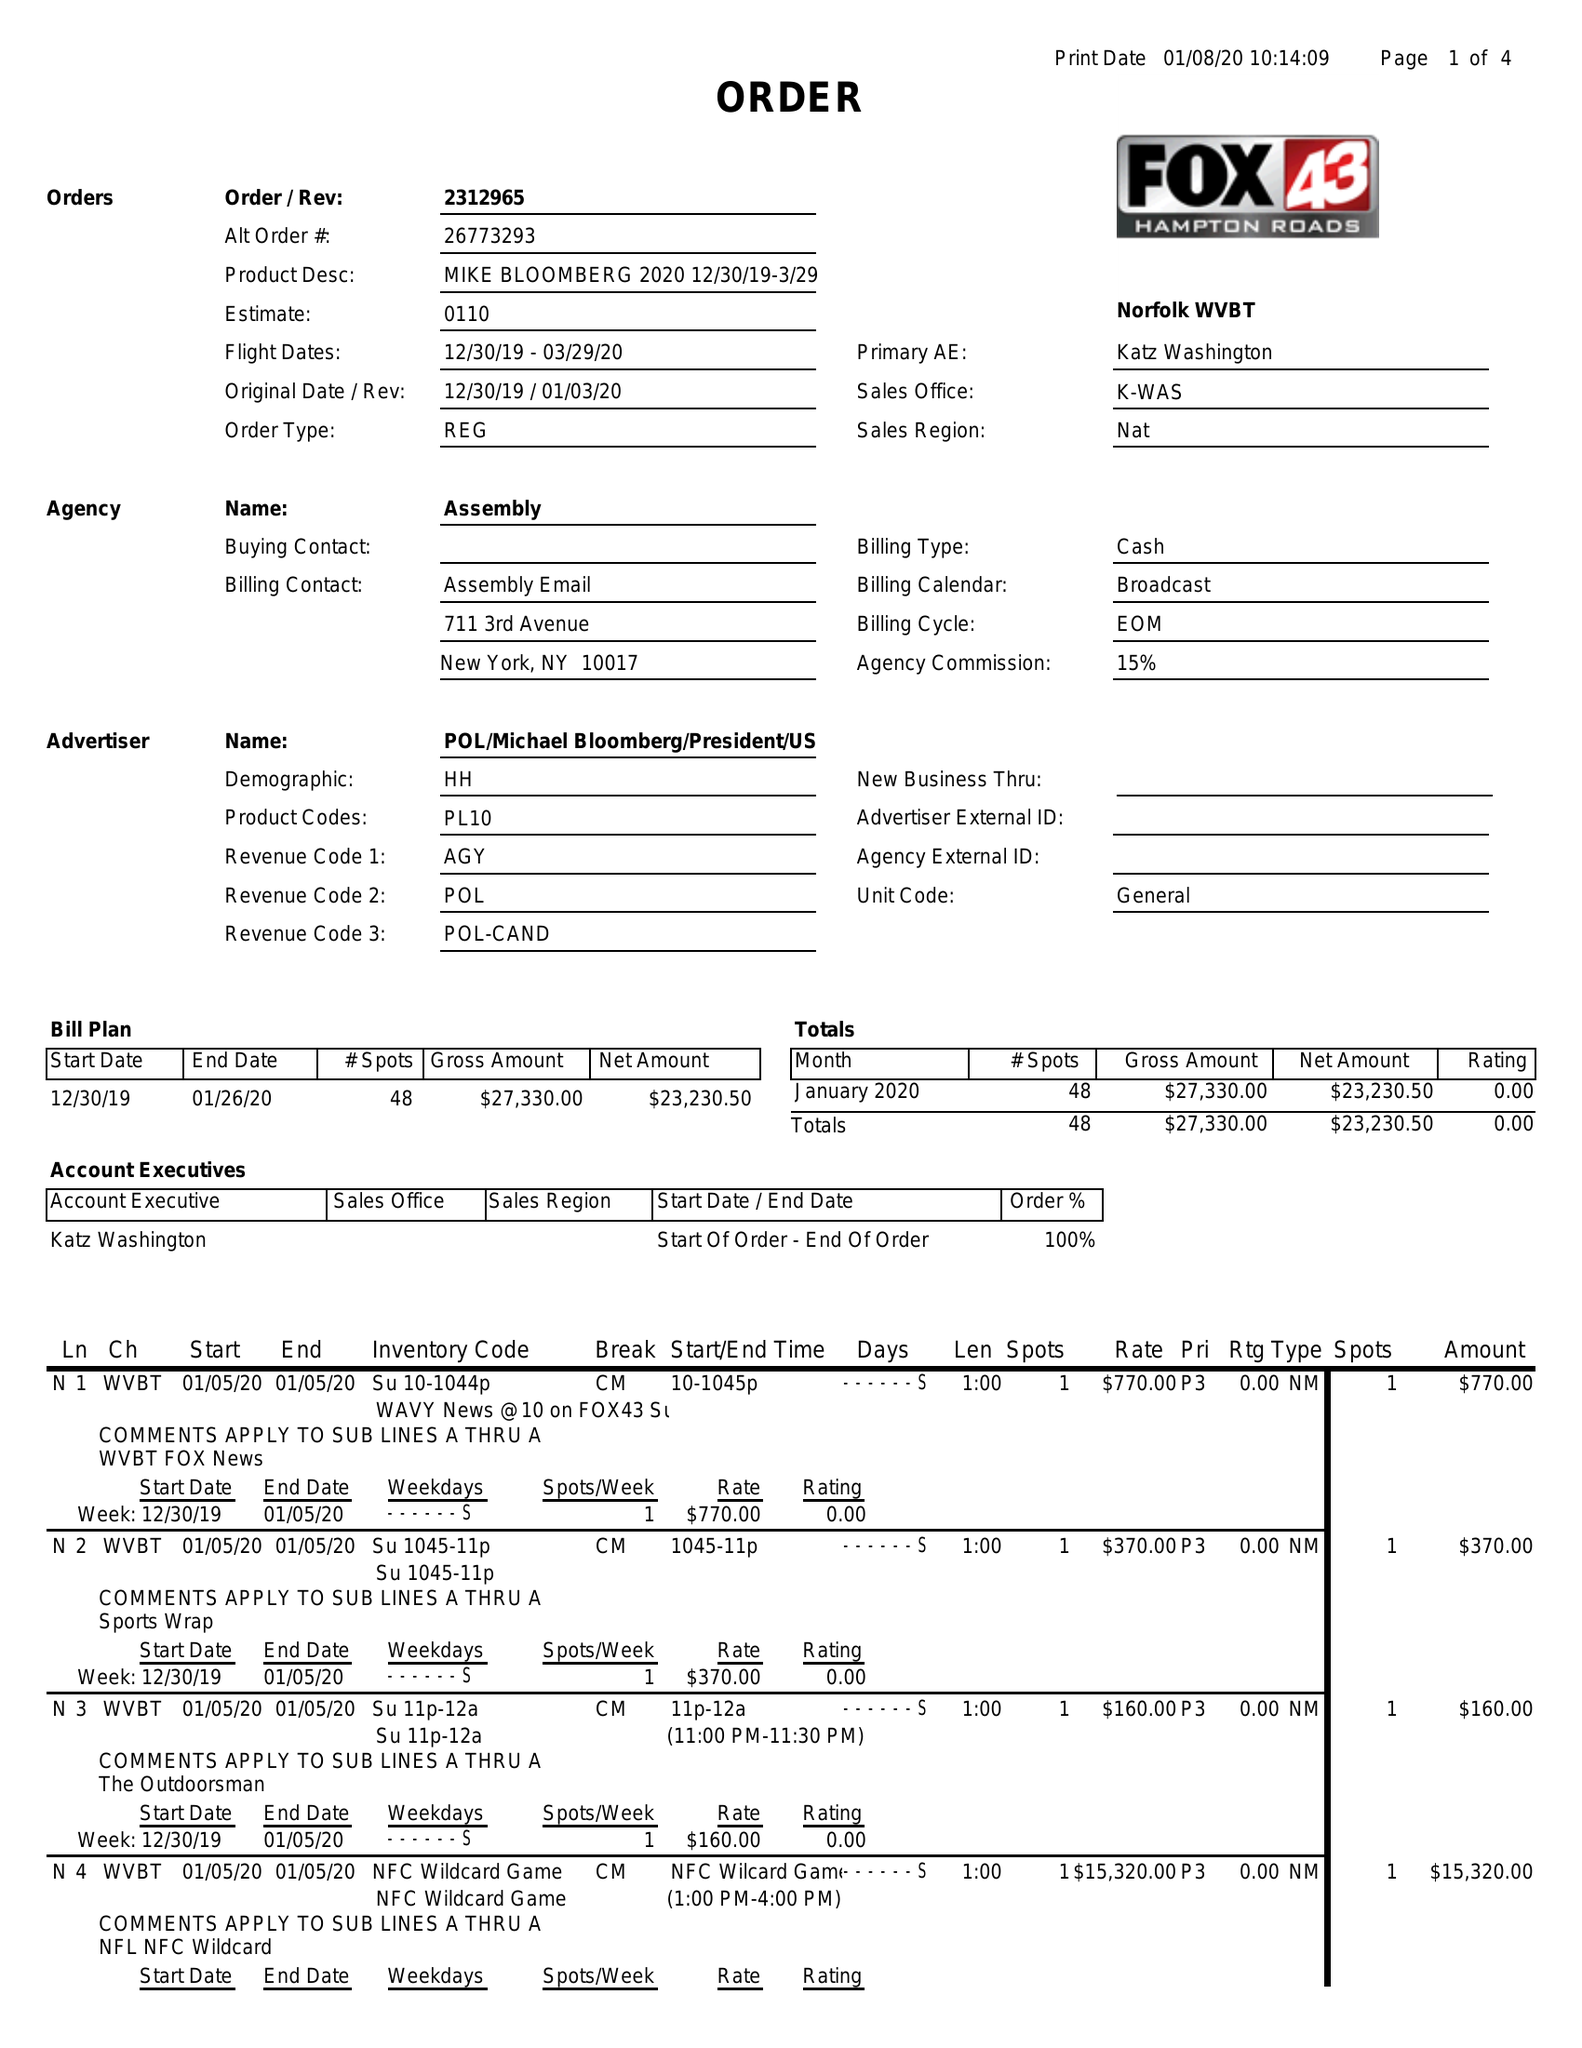What is the value for the flight_to?
Answer the question using a single word or phrase. 03/29/20 